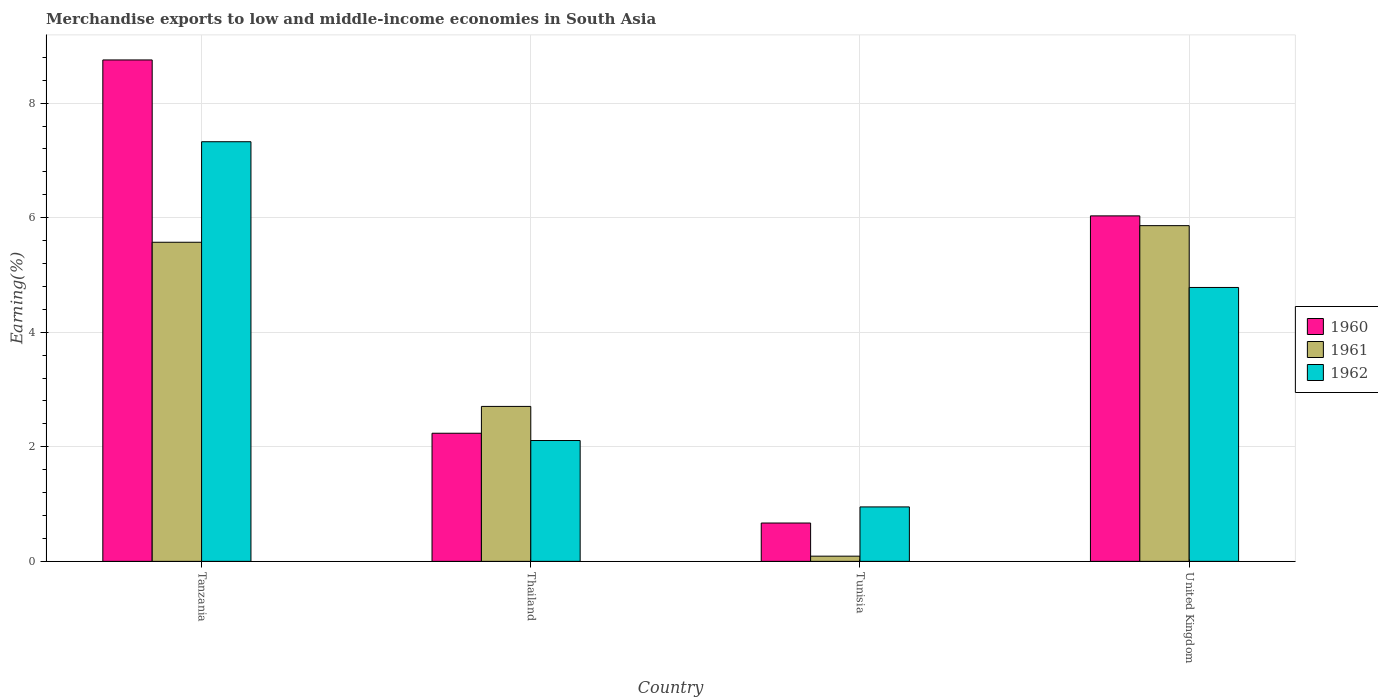How many groups of bars are there?
Keep it short and to the point. 4. Are the number of bars per tick equal to the number of legend labels?
Make the answer very short. Yes. How many bars are there on the 4th tick from the left?
Ensure brevity in your answer.  3. What is the label of the 4th group of bars from the left?
Offer a terse response. United Kingdom. In how many cases, is the number of bars for a given country not equal to the number of legend labels?
Provide a succinct answer. 0. What is the percentage of amount earned from merchandise exports in 1960 in Tunisia?
Offer a terse response. 0.67. Across all countries, what is the maximum percentage of amount earned from merchandise exports in 1960?
Provide a succinct answer. 8.75. Across all countries, what is the minimum percentage of amount earned from merchandise exports in 1961?
Make the answer very short. 0.09. In which country was the percentage of amount earned from merchandise exports in 1961 maximum?
Offer a terse response. United Kingdom. In which country was the percentage of amount earned from merchandise exports in 1961 minimum?
Your response must be concise. Tunisia. What is the total percentage of amount earned from merchandise exports in 1962 in the graph?
Your answer should be compact. 15.17. What is the difference between the percentage of amount earned from merchandise exports in 1962 in Tanzania and that in United Kingdom?
Ensure brevity in your answer.  2.54. What is the difference between the percentage of amount earned from merchandise exports in 1960 in Thailand and the percentage of amount earned from merchandise exports in 1962 in Tunisia?
Ensure brevity in your answer.  1.29. What is the average percentage of amount earned from merchandise exports in 1961 per country?
Your answer should be compact. 3.56. What is the difference between the percentage of amount earned from merchandise exports of/in 1962 and percentage of amount earned from merchandise exports of/in 1960 in United Kingdom?
Give a very brief answer. -1.25. What is the ratio of the percentage of amount earned from merchandise exports in 1960 in Tanzania to that in United Kingdom?
Make the answer very short. 1.45. Is the percentage of amount earned from merchandise exports in 1961 in Tunisia less than that in United Kingdom?
Give a very brief answer. Yes. Is the difference between the percentage of amount earned from merchandise exports in 1962 in Thailand and United Kingdom greater than the difference between the percentage of amount earned from merchandise exports in 1960 in Thailand and United Kingdom?
Provide a succinct answer. Yes. What is the difference between the highest and the second highest percentage of amount earned from merchandise exports in 1962?
Make the answer very short. -2.67. What is the difference between the highest and the lowest percentage of amount earned from merchandise exports in 1961?
Ensure brevity in your answer.  5.77. In how many countries, is the percentage of amount earned from merchandise exports in 1961 greater than the average percentage of amount earned from merchandise exports in 1961 taken over all countries?
Your answer should be very brief. 2. Is the sum of the percentage of amount earned from merchandise exports in 1961 in Tanzania and Thailand greater than the maximum percentage of amount earned from merchandise exports in 1960 across all countries?
Keep it short and to the point. No. Is it the case that in every country, the sum of the percentage of amount earned from merchandise exports in 1960 and percentage of amount earned from merchandise exports in 1961 is greater than the percentage of amount earned from merchandise exports in 1962?
Ensure brevity in your answer.  No. How many bars are there?
Ensure brevity in your answer.  12. Are all the bars in the graph horizontal?
Your answer should be very brief. No. Are the values on the major ticks of Y-axis written in scientific E-notation?
Your answer should be compact. No. Does the graph contain grids?
Offer a terse response. Yes. How are the legend labels stacked?
Give a very brief answer. Vertical. What is the title of the graph?
Make the answer very short. Merchandise exports to low and middle-income economies in South Asia. What is the label or title of the X-axis?
Keep it short and to the point. Country. What is the label or title of the Y-axis?
Make the answer very short. Earning(%). What is the Earning(%) in 1960 in Tanzania?
Make the answer very short. 8.75. What is the Earning(%) of 1961 in Tanzania?
Give a very brief answer. 5.57. What is the Earning(%) of 1962 in Tanzania?
Make the answer very short. 7.33. What is the Earning(%) of 1960 in Thailand?
Provide a succinct answer. 2.24. What is the Earning(%) of 1961 in Thailand?
Make the answer very short. 2.71. What is the Earning(%) of 1962 in Thailand?
Your answer should be compact. 2.11. What is the Earning(%) of 1960 in Tunisia?
Keep it short and to the point. 0.67. What is the Earning(%) of 1961 in Tunisia?
Offer a very short reply. 0.09. What is the Earning(%) of 1962 in Tunisia?
Your answer should be very brief. 0.95. What is the Earning(%) in 1960 in United Kingdom?
Provide a short and direct response. 6.03. What is the Earning(%) of 1961 in United Kingdom?
Keep it short and to the point. 5.86. What is the Earning(%) in 1962 in United Kingdom?
Provide a succinct answer. 4.78. Across all countries, what is the maximum Earning(%) in 1960?
Provide a short and direct response. 8.75. Across all countries, what is the maximum Earning(%) in 1961?
Provide a short and direct response. 5.86. Across all countries, what is the maximum Earning(%) of 1962?
Give a very brief answer. 7.33. Across all countries, what is the minimum Earning(%) in 1960?
Ensure brevity in your answer.  0.67. Across all countries, what is the minimum Earning(%) in 1961?
Your answer should be very brief. 0.09. Across all countries, what is the minimum Earning(%) in 1962?
Offer a very short reply. 0.95. What is the total Earning(%) of 1960 in the graph?
Offer a very short reply. 17.69. What is the total Earning(%) of 1961 in the graph?
Your answer should be very brief. 14.23. What is the total Earning(%) in 1962 in the graph?
Make the answer very short. 15.17. What is the difference between the Earning(%) of 1960 in Tanzania and that in Thailand?
Keep it short and to the point. 6.52. What is the difference between the Earning(%) in 1961 in Tanzania and that in Thailand?
Offer a very short reply. 2.87. What is the difference between the Earning(%) in 1962 in Tanzania and that in Thailand?
Make the answer very short. 5.22. What is the difference between the Earning(%) of 1960 in Tanzania and that in Tunisia?
Offer a very short reply. 8.09. What is the difference between the Earning(%) of 1961 in Tanzania and that in Tunisia?
Your answer should be very brief. 5.48. What is the difference between the Earning(%) in 1962 in Tanzania and that in Tunisia?
Offer a terse response. 6.38. What is the difference between the Earning(%) in 1960 in Tanzania and that in United Kingdom?
Give a very brief answer. 2.72. What is the difference between the Earning(%) in 1961 in Tanzania and that in United Kingdom?
Your answer should be compact. -0.29. What is the difference between the Earning(%) of 1962 in Tanzania and that in United Kingdom?
Offer a very short reply. 2.54. What is the difference between the Earning(%) of 1960 in Thailand and that in Tunisia?
Offer a terse response. 1.57. What is the difference between the Earning(%) in 1961 in Thailand and that in Tunisia?
Offer a very short reply. 2.61. What is the difference between the Earning(%) in 1962 in Thailand and that in Tunisia?
Provide a short and direct response. 1.16. What is the difference between the Earning(%) in 1960 in Thailand and that in United Kingdom?
Offer a terse response. -3.8. What is the difference between the Earning(%) of 1961 in Thailand and that in United Kingdom?
Ensure brevity in your answer.  -3.16. What is the difference between the Earning(%) of 1962 in Thailand and that in United Kingdom?
Your answer should be compact. -2.67. What is the difference between the Earning(%) of 1960 in Tunisia and that in United Kingdom?
Offer a terse response. -5.36. What is the difference between the Earning(%) of 1961 in Tunisia and that in United Kingdom?
Offer a very short reply. -5.77. What is the difference between the Earning(%) in 1962 in Tunisia and that in United Kingdom?
Make the answer very short. -3.83. What is the difference between the Earning(%) in 1960 in Tanzania and the Earning(%) in 1961 in Thailand?
Give a very brief answer. 6.05. What is the difference between the Earning(%) in 1960 in Tanzania and the Earning(%) in 1962 in Thailand?
Ensure brevity in your answer.  6.64. What is the difference between the Earning(%) of 1961 in Tanzania and the Earning(%) of 1962 in Thailand?
Make the answer very short. 3.46. What is the difference between the Earning(%) in 1960 in Tanzania and the Earning(%) in 1961 in Tunisia?
Provide a succinct answer. 8.66. What is the difference between the Earning(%) of 1960 in Tanzania and the Earning(%) of 1962 in Tunisia?
Make the answer very short. 7.8. What is the difference between the Earning(%) in 1961 in Tanzania and the Earning(%) in 1962 in Tunisia?
Offer a very short reply. 4.62. What is the difference between the Earning(%) of 1960 in Tanzania and the Earning(%) of 1961 in United Kingdom?
Your response must be concise. 2.89. What is the difference between the Earning(%) in 1960 in Tanzania and the Earning(%) in 1962 in United Kingdom?
Give a very brief answer. 3.97. What is the difference between the Earning(%) in 1961 in Tanzania and the Earning(%) in 1962 in United Kingdom?
Keep it short and to the point. 0.79. What is the difference between the Earning(%) of 1960 in Thailand and the Earning(%) of 1961 in Tunisia?
Provide a short and direct response. 2.15. What is the difference between the Earning(%) of 1960 in Thailand and the Earning(%) of 1962 in Tunisia?
Your answer should be compact. 1.29. What is the difference between the Earning(%) in 1961 in Thailand and the Earning(%) in 1962 in Tunisia?
Make the answer very short. 1.75. What is the difference between the Earning(%) in 1960 in Thailand and the Earning(%) in 1961 in United Kingdom?
Your answer should be compact. -3.62. What is the difference between the Earning(%) in 1960 in Thailand and the Earning(%) in 1962 in United Kingdom?
Make the answer very short. -2.55. What is the difference between the Earning(%) of 1961 in Thailand and the Earning(%) of 1962 in United Kingdom?
Ensure brevity in your answer.  -2.08. What is the difference between the Earning(%) in 1960 in Tunisia and the Earning(%) in 1961 in United Kingdom?
Provide a short and direct response. -5.19. What is the difference between the Earning(%) in 1960 in Tunisia and the Earning(%) in 1962 in United Kingdom?
Ensure brevity in your answer.  -4.11. What is the difference between the Earning(%) of 1961 in Tunisia and the Earning(%) of 1962 in United Kingdom?
Offer a very short reply. -4.69. What is the average Earning(%) of 1960 per country?
Keep it short and to the point. 4.42. What is the average Earning(%) in 1961 per country?
Ensure brevity in your answer.  3.56. What is the average Earning(%) of 1962 per country?
Give a very brief answer. 3.79. What is the difference between the Earning(%) of 1960 and Earning(%) of 1961 in Tanzania?
Ensure brevity in your answer.  3.18. What is the difference between the Earning(%) in 1960 and Earning(%) in 1962 in Tanzania?
Give a very brief answer. 1.43. What is the difference between the Earning(%) of 1961 and Earning(%) of 1962 in Tanzania?
Offer a very short reply. -1.76. What is the difference between the Earning(%) of 1960 and Earning(%) of 1961 in Thailand?
Provide a short and direct response. -0.47. What is the difference between the Earning(%) of 1960 and Earning(%) of 1962 in Thailand?
Give a very brief answer. 0.13. What is the difference between the Earning(%) of 1961 and Earning(%) of 1962 in Thailand?
Provide a short and direct response. 0.6. What is the difference between the Earning(%) of 1960 and Earning(%) of 1961 in Tunisia?
Your answer should be compact. 0.58. What is the difference between the Earning(%) of 1960 and Earning(%) of 1962 in Tunisia?
Offer a terse response. -0.28. What is the difference between the Earning(%) in 1961 and Earning(%) in 1962 in Tunisia?
Keep it short and to the point. -0.86. What is the difference between the Earning(%) in 1960 and Earning(%) in 1961 in United Kingdom?
Keep it short and to the point. 0.17. What is the difference between the Earning(%) in 1960 and Earning(%) in 1962 in United Kingdom?
Make the answer very short. 1.25. What is the difference between the Earning(%) of 1961 and Earning(%) of 1962 in United Kingdom?
Give a very brief answer. 1.08. What is the ratio of the Earning(%) of 1960 in Tanzania to that in Thailand?
Offer a very short reply. 3.91. What is the ratio of the Earning(%) of 1961 in Tanzania to that in Thailand?
Keep it short and to the point. 2.06. What is the ratio of the Earning(%) of 1962 in Tanzania to that in Thailand?
Offer a very short reply. 3.47. What is the ratio of the Earning(%) in 1960 in Tanzania to that in Tunisia?
Provide a short and direct response. 13.08. What is the ratio of the Earning(%) in 1961 in Tanzania to that in Tunisia?
Your response must be concise. 61.46. What is the ratio of the Earning(%) of 1962 in Tanzania to that in Tunisia?
Keep it short and to the point. 7.71. What is the ratio of the Earning(%) of 1960 in Tanzania to that in United Kingdom?
Your answer should be very brief. 1.45. What is the ratio of the Earning(%) in 1961 in Tanzania to that in United Kingdom?
Give a very brief answer. 0.95. What is the ratio of the Earning(%) in 1962 in Tanzania to that in United Kingdom?
Ensure brevity in your answer.  1.53. What is the ratio of the Earning(%) of 1960 in Thailand to that in Tunisia?
Offer a terse response. 3.34. What is the ratio of the Earning(%) of 1961 in Thailand to that in Tunisia?
Your response must be concise. 29.84. What is the ratio of the Earning(%) of 1962 in Thailand to that in Tunisia?
Your response must be concise. 2.22. What is the ratio of the Earning(%) of 1960 in Thailand to that in United Kingdom?
Keep it short and to the point. 0.37. What is the ratio of the Earning(%) in 1961 in Thailand to that in United Kingdom?
Provide a short and direct response. 0.46. What is the ratio of the Earning(%) of 1962 in Thailand to that in United Kingdom?
Keep it short and to the point. 0.44. What is the ratio of the Earning(%) of 1960 in Tunisia to that in United Kingdom?
Your response must be concise. 0.11. What is the ratio of the Earning(%) of 1961 in Tunisia to that in United Kingdom?
Your answer should be very brief. 0.02. What is the ratio of the Earning(%) of 1962 in Tunisia to that in United Kingdom?
Your answer should be very brief. 0.2. What is the difference between the highest and the second highest Earning(%) in 1960?
Make the answer very short. 2.72. What is the difference between the highest and the second highest Earning(%) of 1961?
Your answer should be compact. 0.29. What is the difference between the highest and the second highest Earning(%) of 1962?
Your answer should be compact. 2.54. What is the difference between the highest and the lowest Earning(%) of 1960?
Your answer should be compact. 8.09. What is the difference between the highest and the lowest Earning(%) in 1961?
Offer a very short reply. 5.77. What is the difference between the highest and the lowest Earning(%) in 1962?
Your response must be concise. 6.38. 